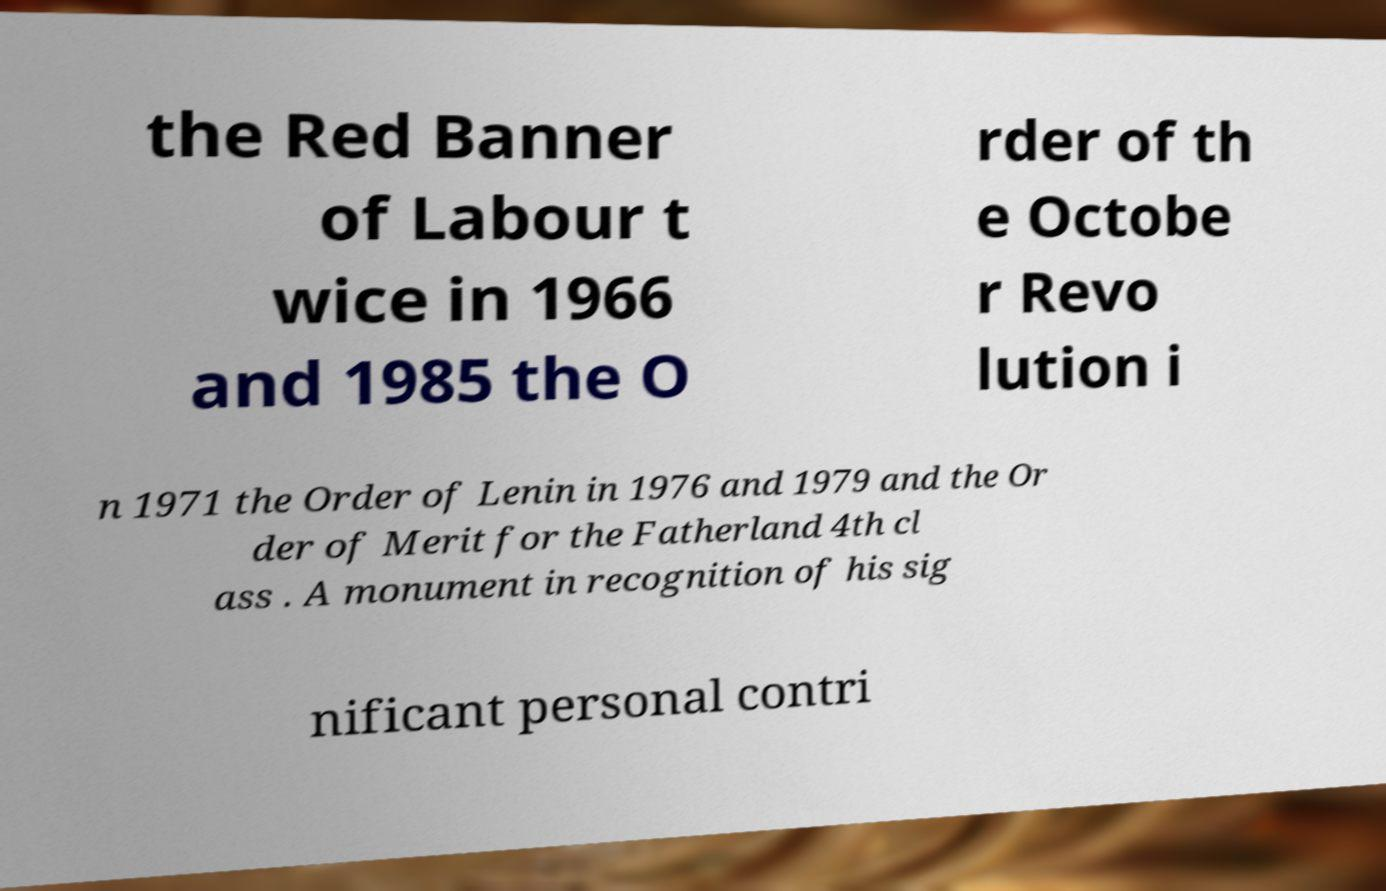Please identify and transcribe the text found in this image. the Red Banner of Labour t wice in 1966 and 1985 the O rder of th e Octobe r Revo lution i n 1971 the Order of Lenin in 1976 and 1979 and the Or der of Merit for the Fatherland 4th cl ass . A monument in recognition of his sig nificant personal contri 